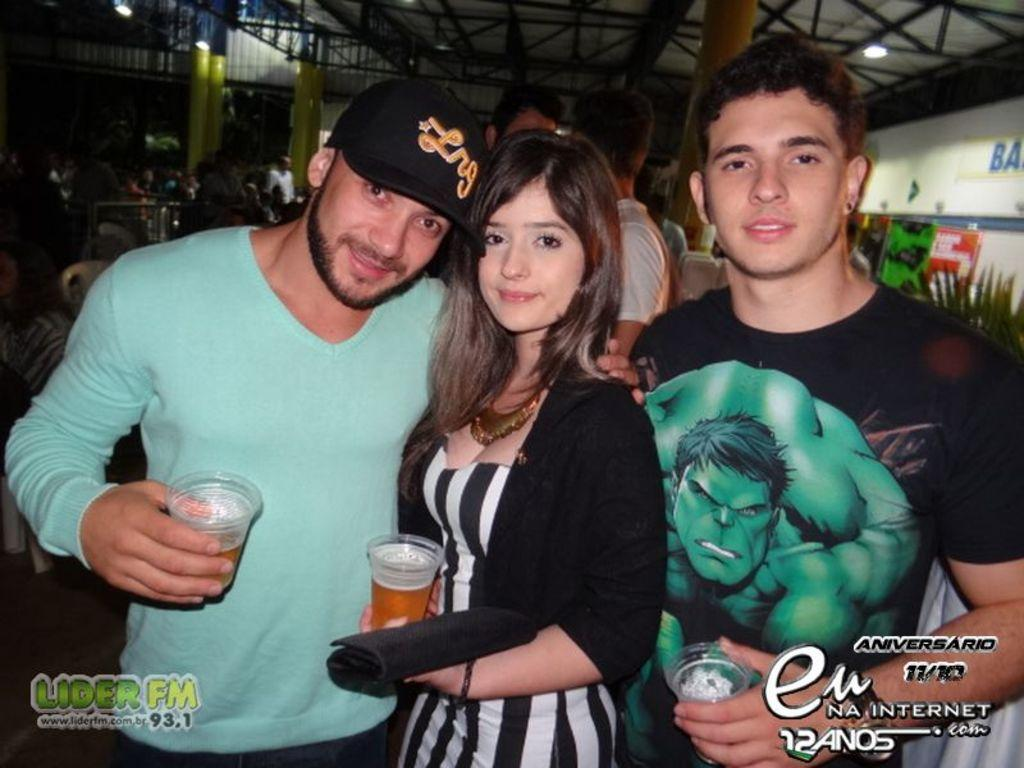How many people are present in the image? There are three individuals in the image: two men and a woman. What are the three individuals holding? The three individuals are holding glasses. Can you describe the group of people in the background of the image? There is a group of people in the background of the image, but their specific characteristics are not discernible from the provided facts. What color is the crayon being used by the creator in the image? There is no crayon or creator present in the image. What type of experience can be gained from observing the individuals in the image? The provided facts do not offer any information about the type of experience that can be gained from observing the individuals in the image. 